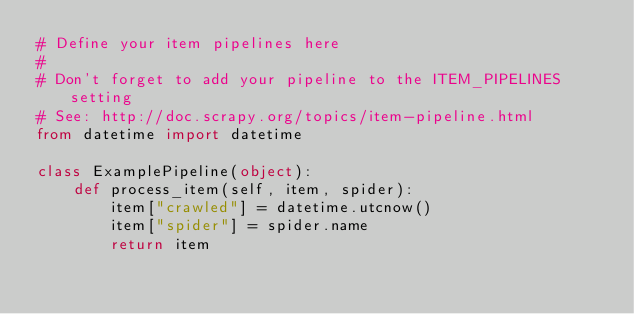<code> <loc_0><loc_0><loc_500><loc_500><_Python_># Define your item pipelines here
#
# Don't forget to add your pipeline to the ITEM_PIPELINES setting
# See: http://doc.scrapy.org/topics/item-pipeline.html
from datetime import datetime

class ExamplePipeline(object):
    def process_item(self, item, spider):
        item["crawled"] = datetime.utcnow()
        item["spider"] = spider.name
        return item
</code> 